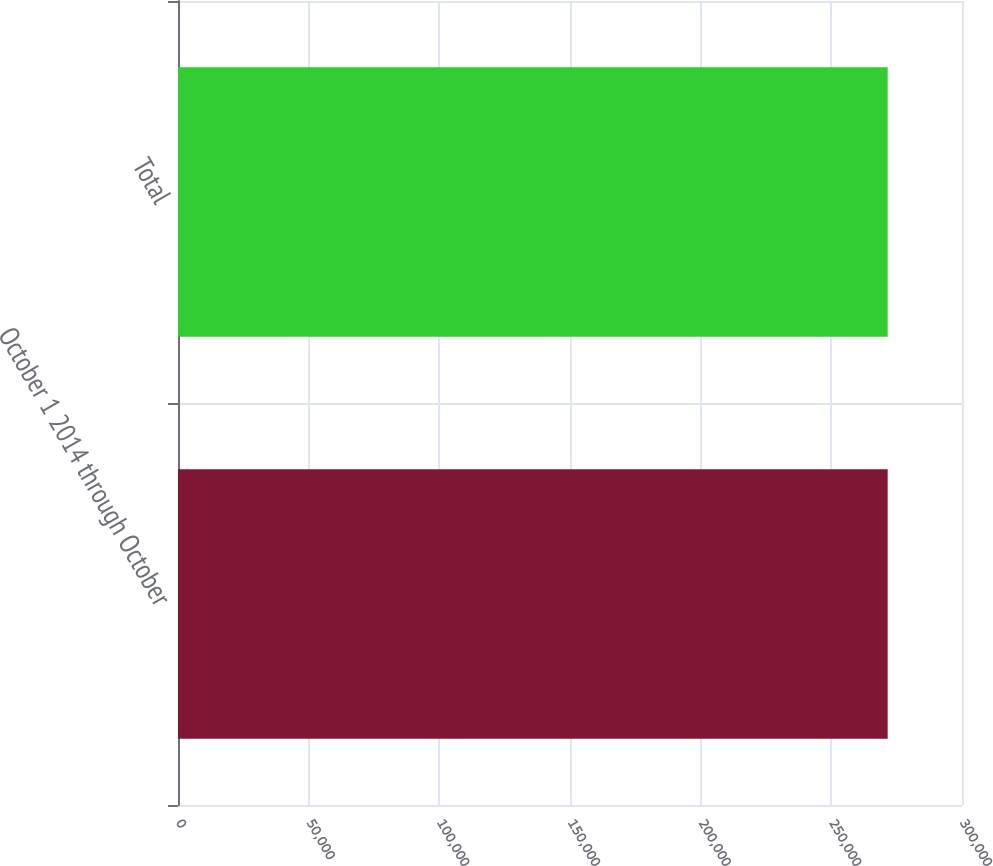<chart> <loc_0><loc_0><loc_500><loc_500><bar_chart><fcel>October 1 2014 through October<fcel>Total<nl><fcel>271559<fcel>271559<nl></chart> 